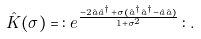Convert formula to latex. <formula><loc_0><loc_0><loc_500><loc_500>\hat { K } ( \sigma ) = \, \colon \, e ^ { \frac { - 2 \hat { a } \hat { a } ^ { \dagger } + \sigma ( \hat { a } ^ { \dagger } \hat { a } ^ { \dagger } - \hat { a } \hat { a } ) } { 1 + { \sigma } ^ { 2 } } } \, \colon \, .</formula> 